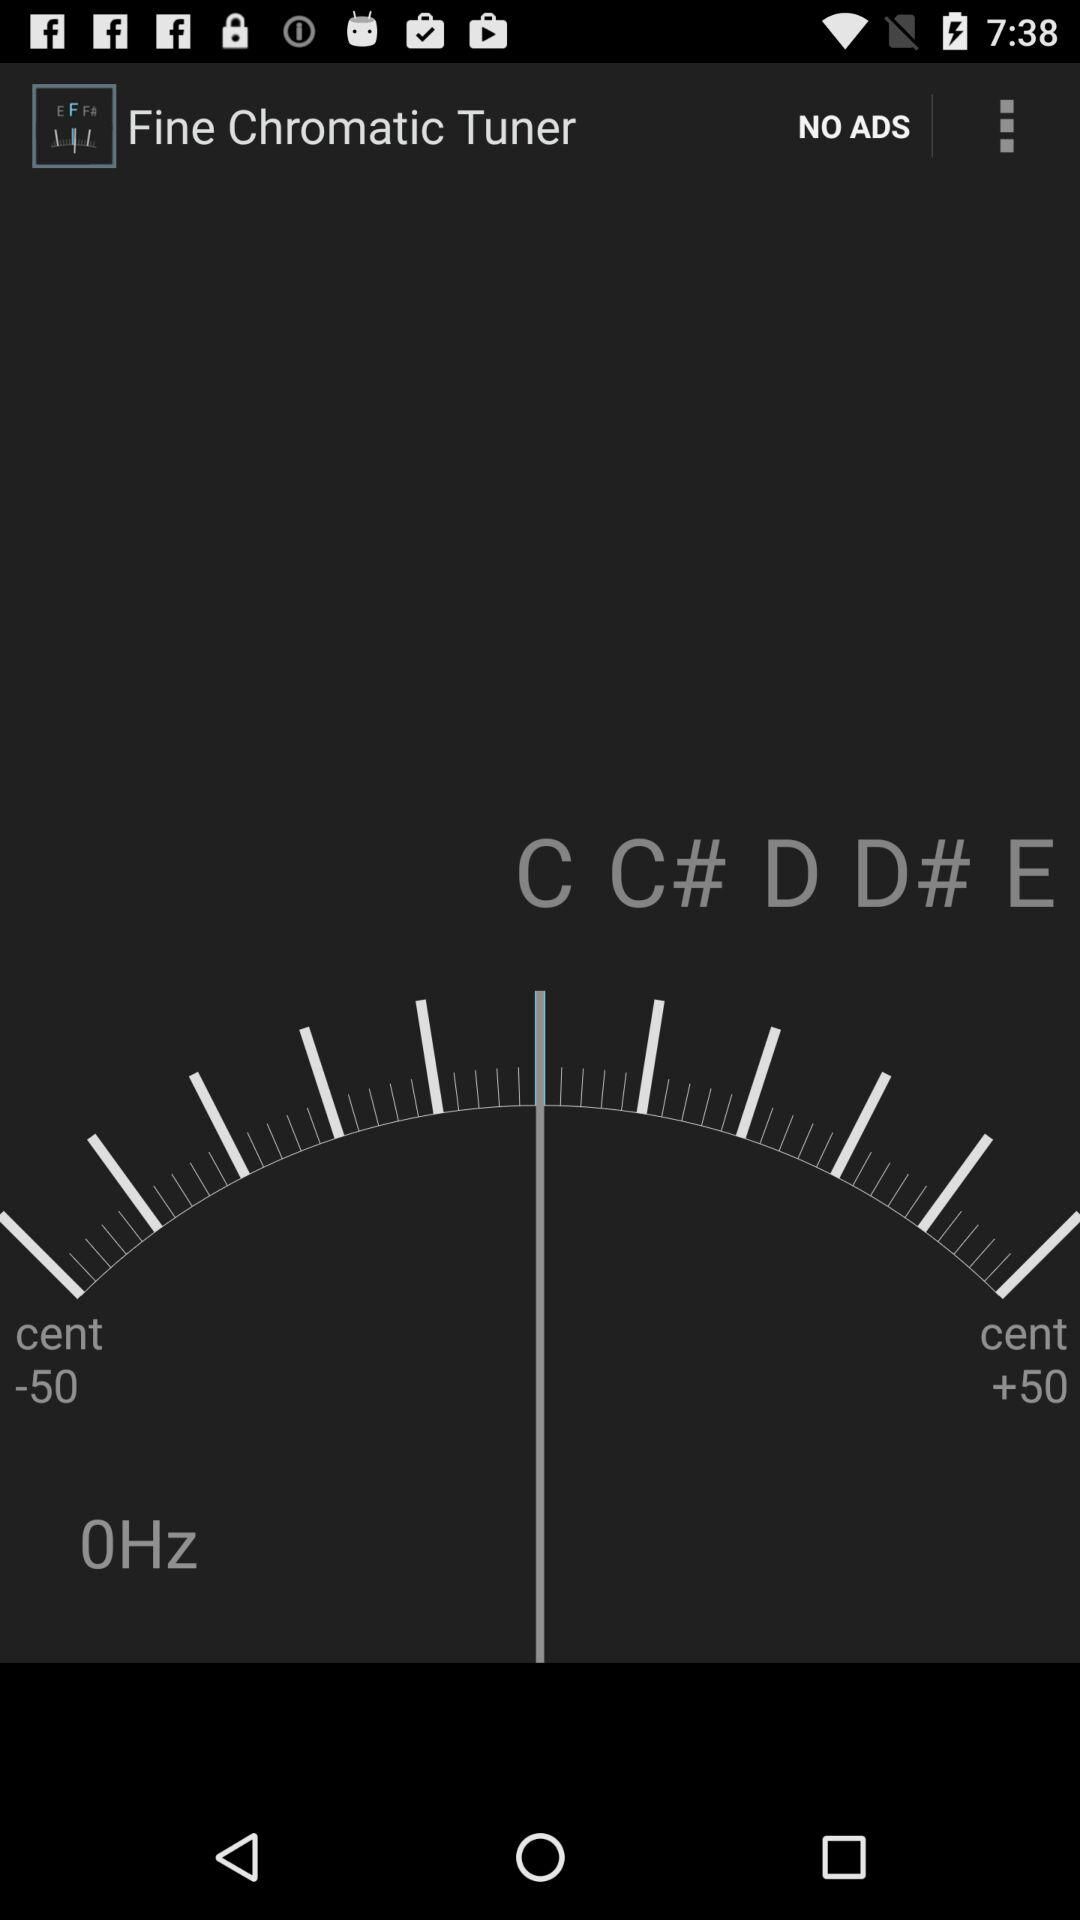What is the app name? The app name is "Fine Chromatic Tuner". 